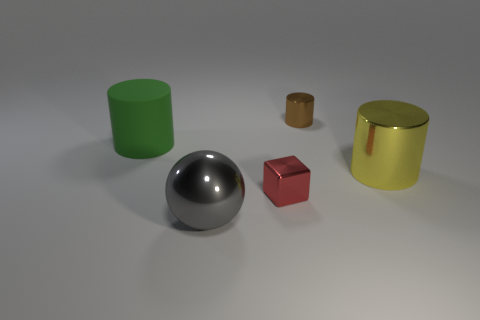How big is the object that is both in front of the big yellow thing and to the left of the red metallic thing?
Make the answer very short. Large. How many cylinders are big purple matte things or big metal things?
Make the answer very short. 1. The cylinder that is the same size as the red metal thing is what color?
Offer a very short reply. Brown. Is there anything else that has the same shape as the tiny brown shiny object?
Your answer should be very brief. Yes. What color is the other tiny thing that is the same shape as the yellow metallic thing?
Your response must be concise. Brown. How many objects are either yellow metal objects or small objects that are behind the red block?
Provide a short and direct response. 2. Are there fewer large metallic cylinders left of the green rubber cylinder than tiny gray metal cubes?
Make the answer very short. No. How big is the shiny cylinder in front of the metallic cylinder behind the metal cylinder in front of the green cylinder?
Offer a terse response. Large. There is a shiny thing that is to the right of the gray shiny ball and in front of the large yellow object; what color is it?
Give a very brief answer. Red. How many brown shiny cylinders are there?
Your answer should be compact. 1. 